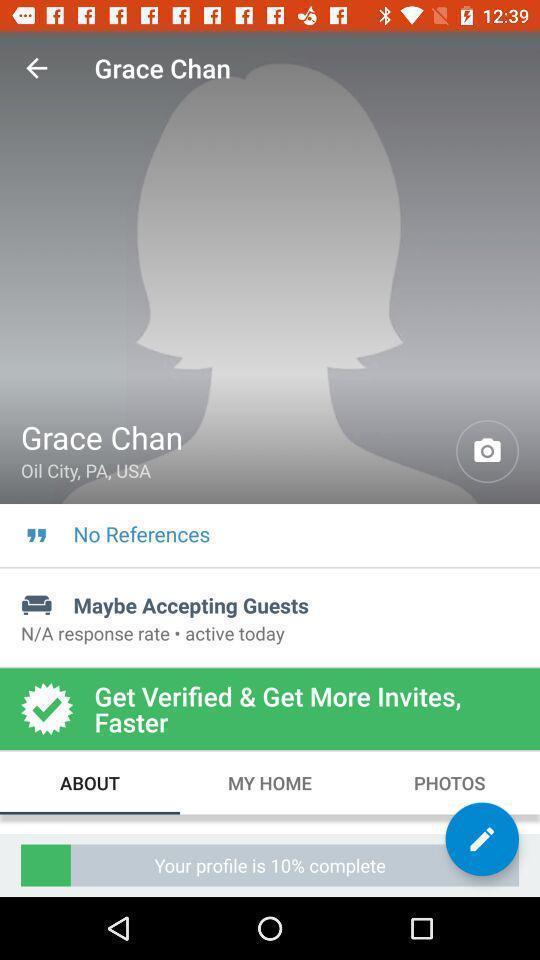What can you discern from this picture? Page showing your profile is 10 complete. 